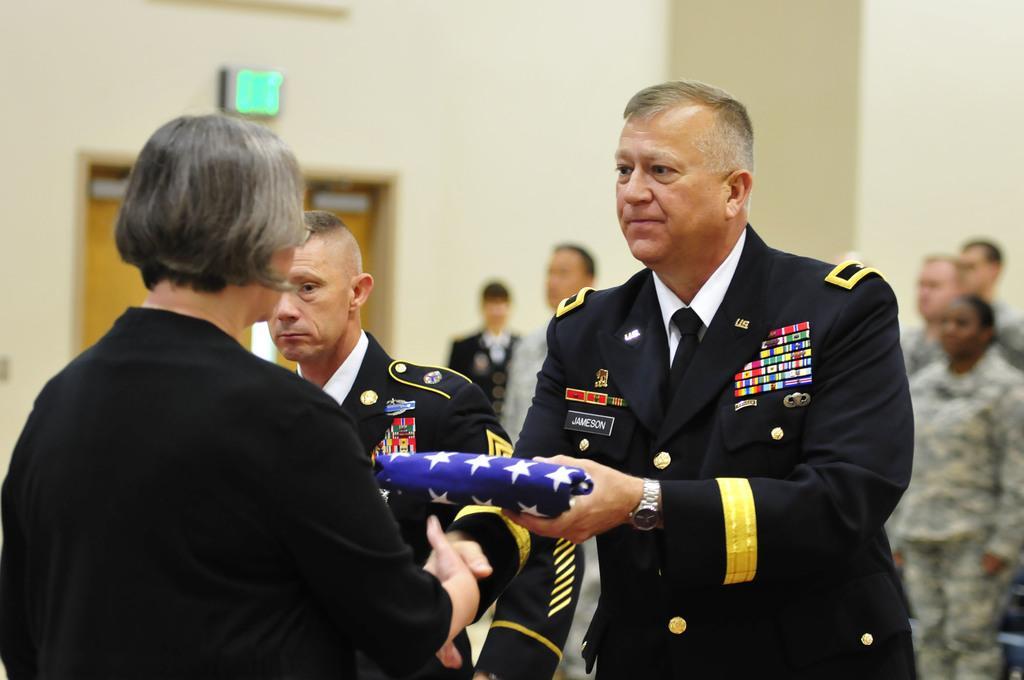How would you summarize this image in a sentence or two? In the picture there is a room, there are many people standing, there is a man holding an object with the hand, behind the man there are people wearing the same costume. 